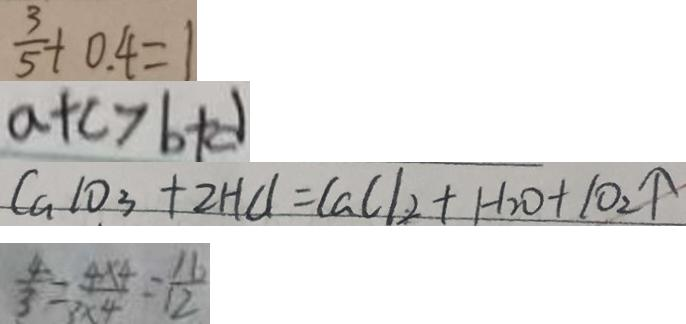<formula> <loc_0><loc_0><loc_500><loc_500>\frac { 3 } { 5 } + 0 . 4 = 1 
 a + c > b + d 
 C a 1 0 _ { 3 } + 2 H C l = C a C l _ { 2 } + H _ { 2 } O + 1 0 _ { 2 } \uparrow 
 \frac { 4 } { 3 } = \frac { 4 \times 4 } { 3 \times 4 } = \frac { 1 6 } { 1 2 }</formula> 